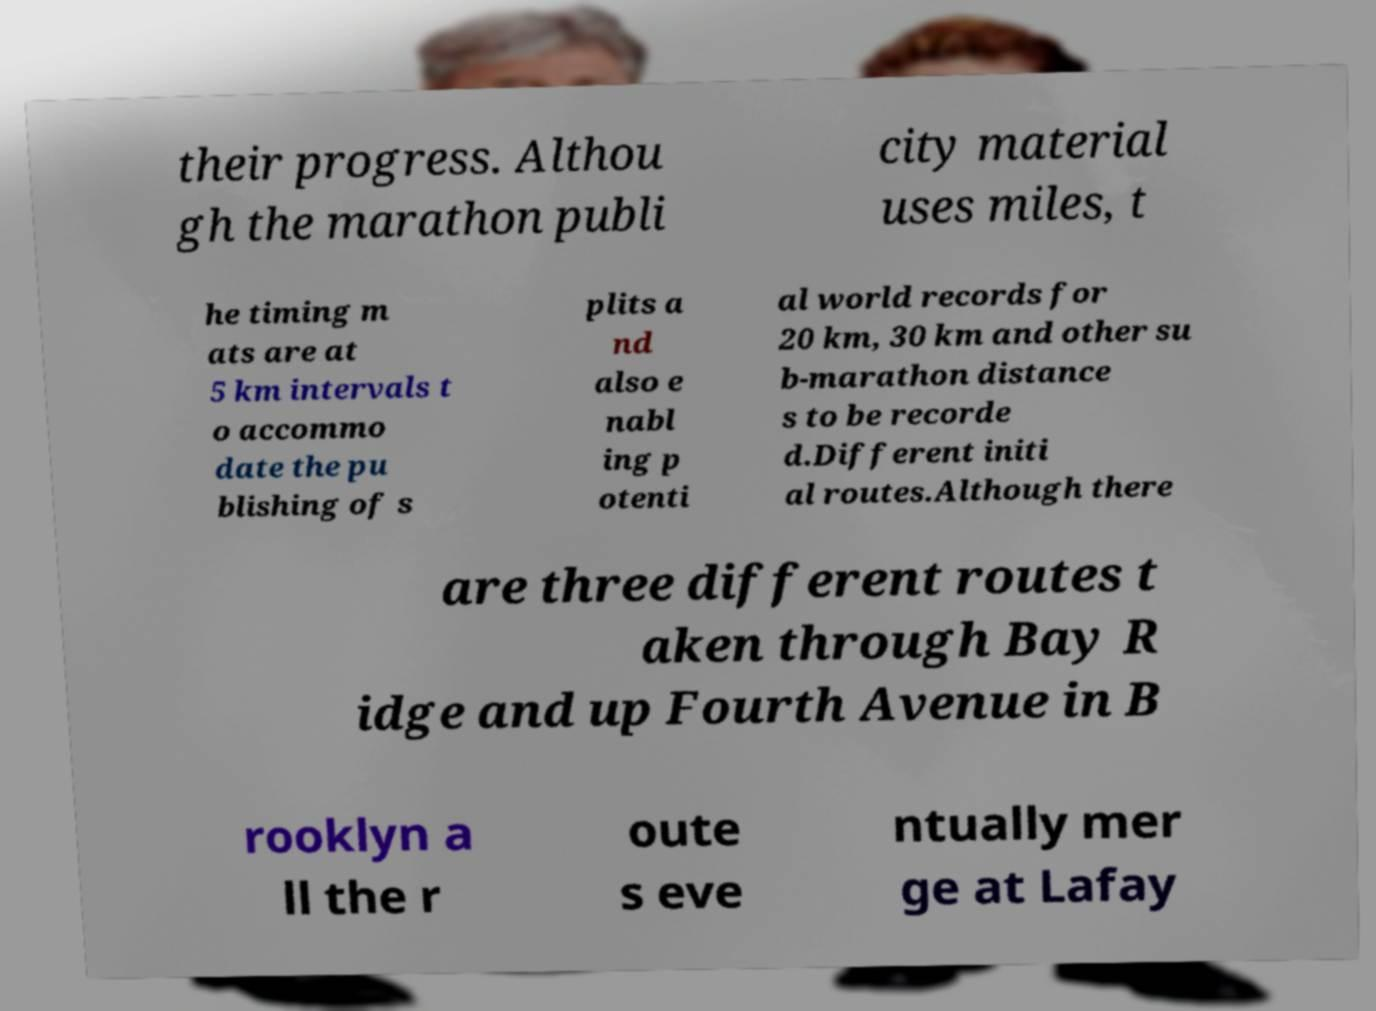For documentation purposes, I need the text within this image transcribed. Could you provide that? their progress. Althou gh the marathon publi city material uses miles, t he timing m ats are at 5 km intervals t o accommo date the pu blishing of s plits a nd also e nabl ing p otenti al world records for 20 km, 30 km and other su b-marathon distance s to be recorde d.Different initi al routes.Although there are three different routes t aken through Bay R idge and up Fourth Avenue in B rooklyn a ll the r oute s eve ntually mer ge at Lafay 